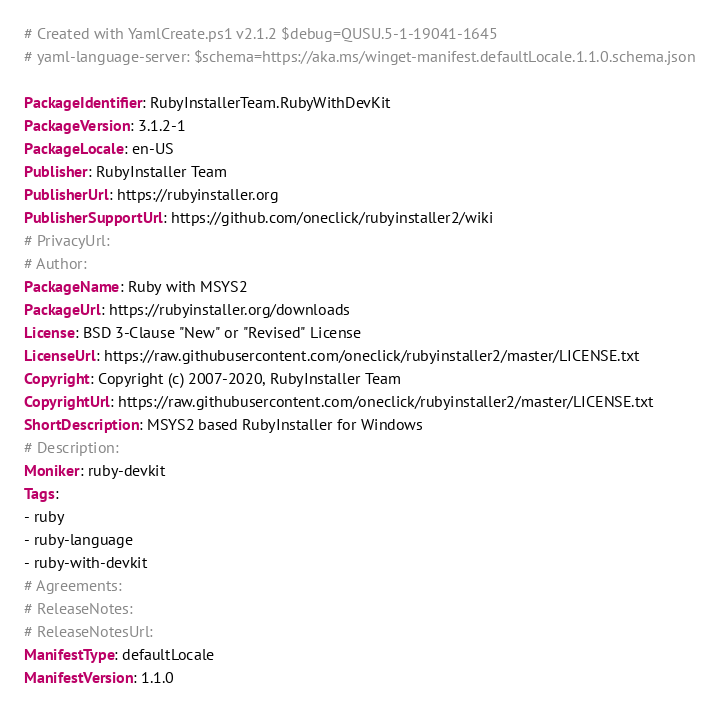<code> <loc_0><loc_0><loc_500><loc_500><_YAML_># Created with YamlCreate.ps1 v2.1.2 $debug=QUSU.5-1-19041-1645
# yaml-language-server: $schema=https://aka.ms/winget-manifest.defaultLocale.1.1.0.schema.json

PackageIdentifier: RubyInstallerTeam.RubyWithDevKit
PackageVersion: 3.1.2-1
PackageLocale: en-US
Publisher: RubyInstaller Team
PublisherUrl: https://rubyinstaller.org
PublisherSupportUrl: https://github.com/oneclick/rubyinstaller2/wiki
# PrivacyUrl: 
# Author: 
PackageName: Ruby with MSYS2
PackageUrl: https://rubyinstaller.org/downloads
License: BSD 3-Clause "New" or "Revised" License
LicenseUrl: https://raw.githubusercontent.com/oneclick/rubyinstaller2/master/LICENSE.txt
Copyright: Copyright (c) 2007-2020, RubyInstaller Team
CopyrightUrl: https://raw.githubusercontent.com/oneclick/rubyinstaller2/master/LICENSE.txt
ShortDescription: MSYS2 based RubyInstaller for Windows
# Description: 
Moniker: ruby-devkit
Tags:
- ruby
- ruby-language
- ruby-with-devkit
# Agreements: 
# ReleaseNotes: 
# ReleaseNotesUrl: 
ManifestType: defaultLocale
ManifestVersion: 1.1.0
</code> 